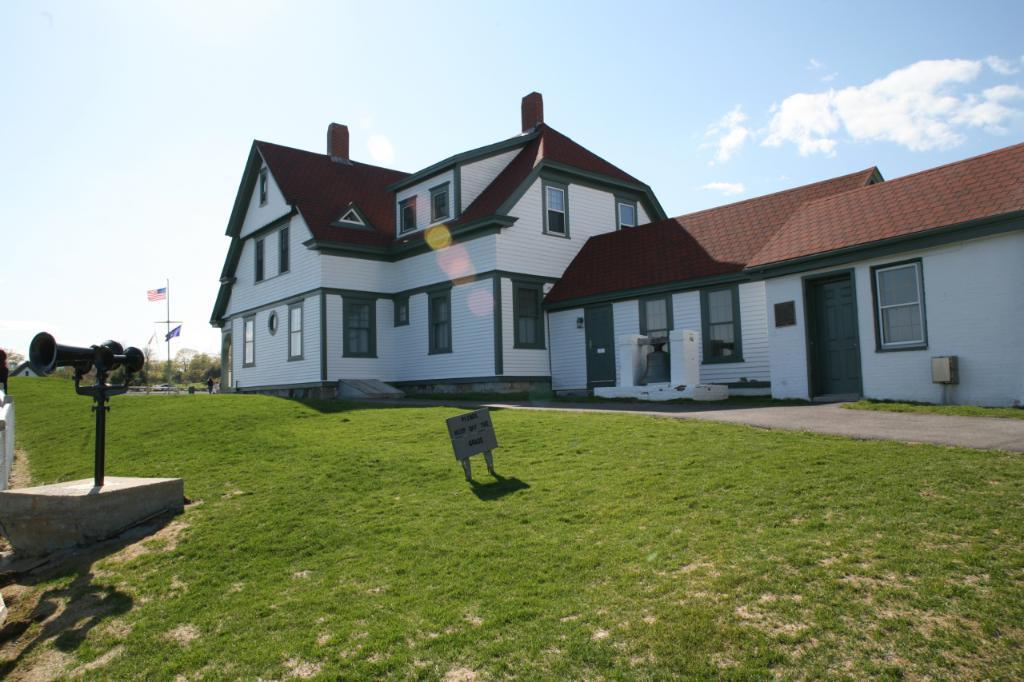What type of structures can be seen in the image? There are buildings in the image. What is on the ground in the image? There is grass and a board on the ground. What can be seen flying in the image? There are flags in the image. What type of vegetation is present in the image? There are trees in the image. How would you describe the sky in the image? The sky is blue and cloudy. What object related to sound is present in the image? There is a horn on a stand. How many stamps are on the board in the image? There are no stamps present in the image; the board is empty. What type of iron is used to press the flags in the image? There is no iron present in the image, and the flags are not being pressed. 